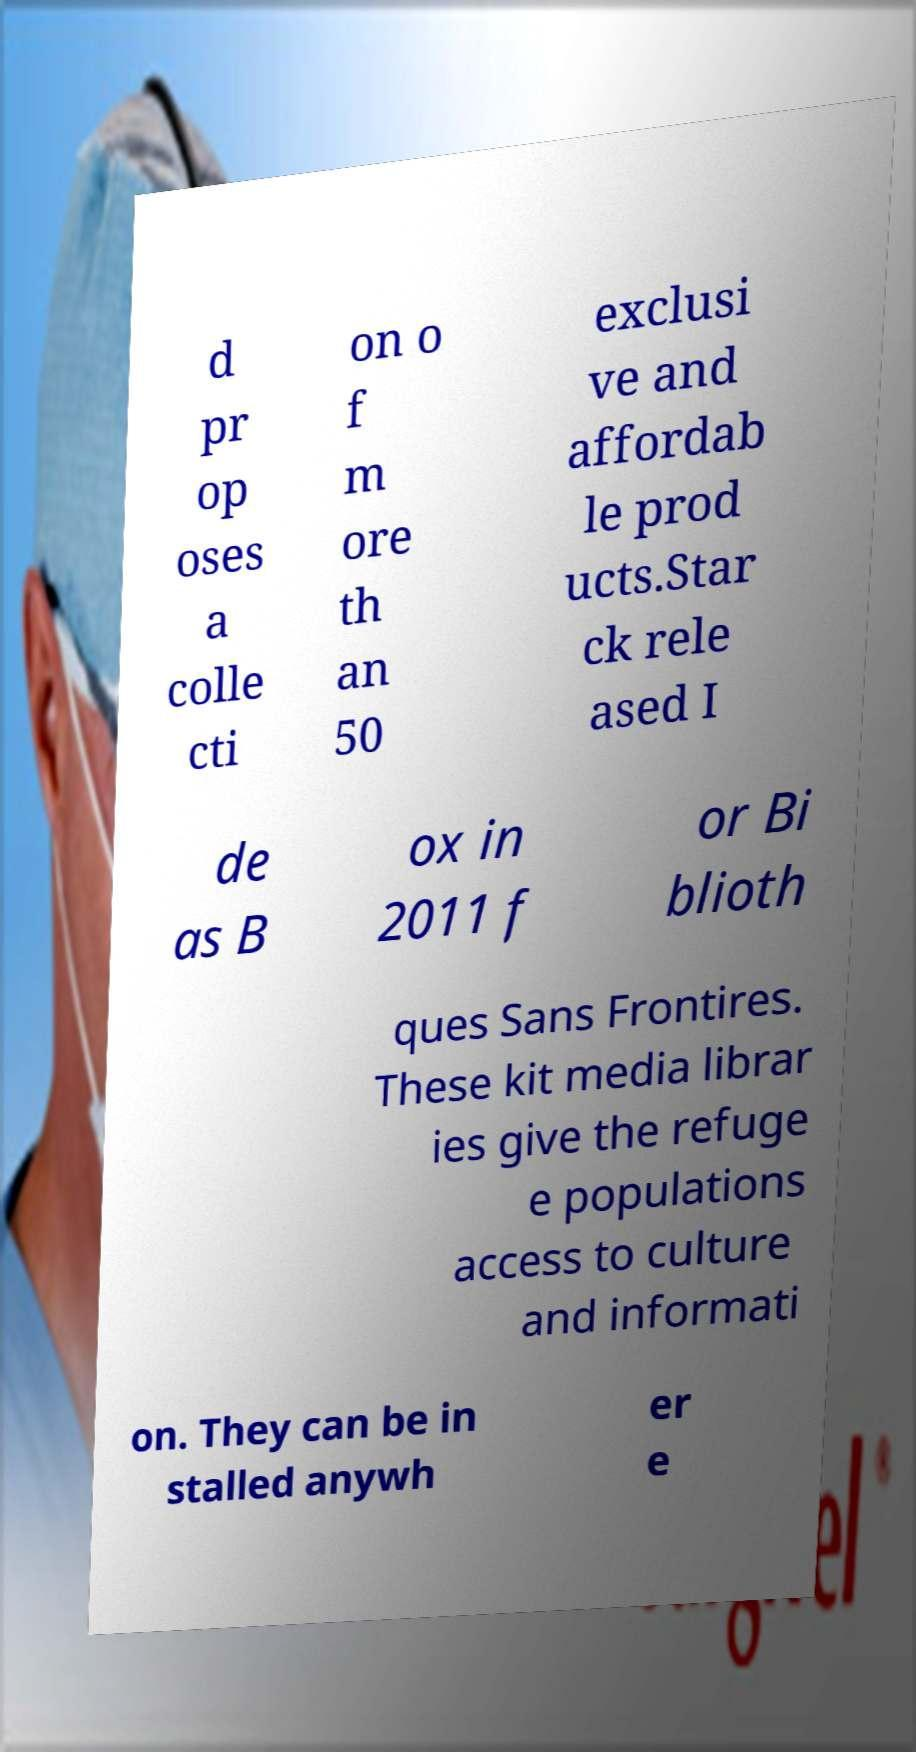I need the written content from this picture converted into text. Can you do that? d pr op oses a colle cti on o f m ore th an 50 exclusi ve and affordab le prod ucts.Star ck rele ased I de as B ox in 2011 f or Bi blioth ques Sans Frontires. These kit media librar ies give the refuge e populations access to culture and informati on. They can be in stalled anywh er e 